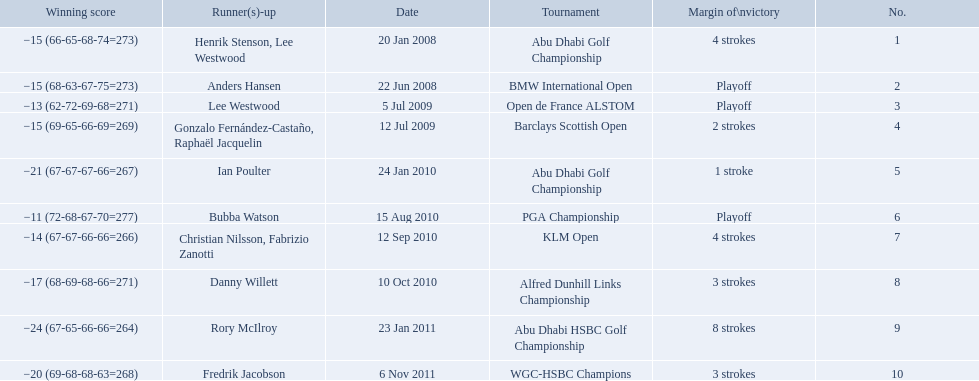How many strokes were in the klm open by martin kaymer? 4 strokes. How many strokes were in the abu dhabi golf championship? 4 strokes. How many more strokes were there in the klm than the barclays open? 2 strokes. 